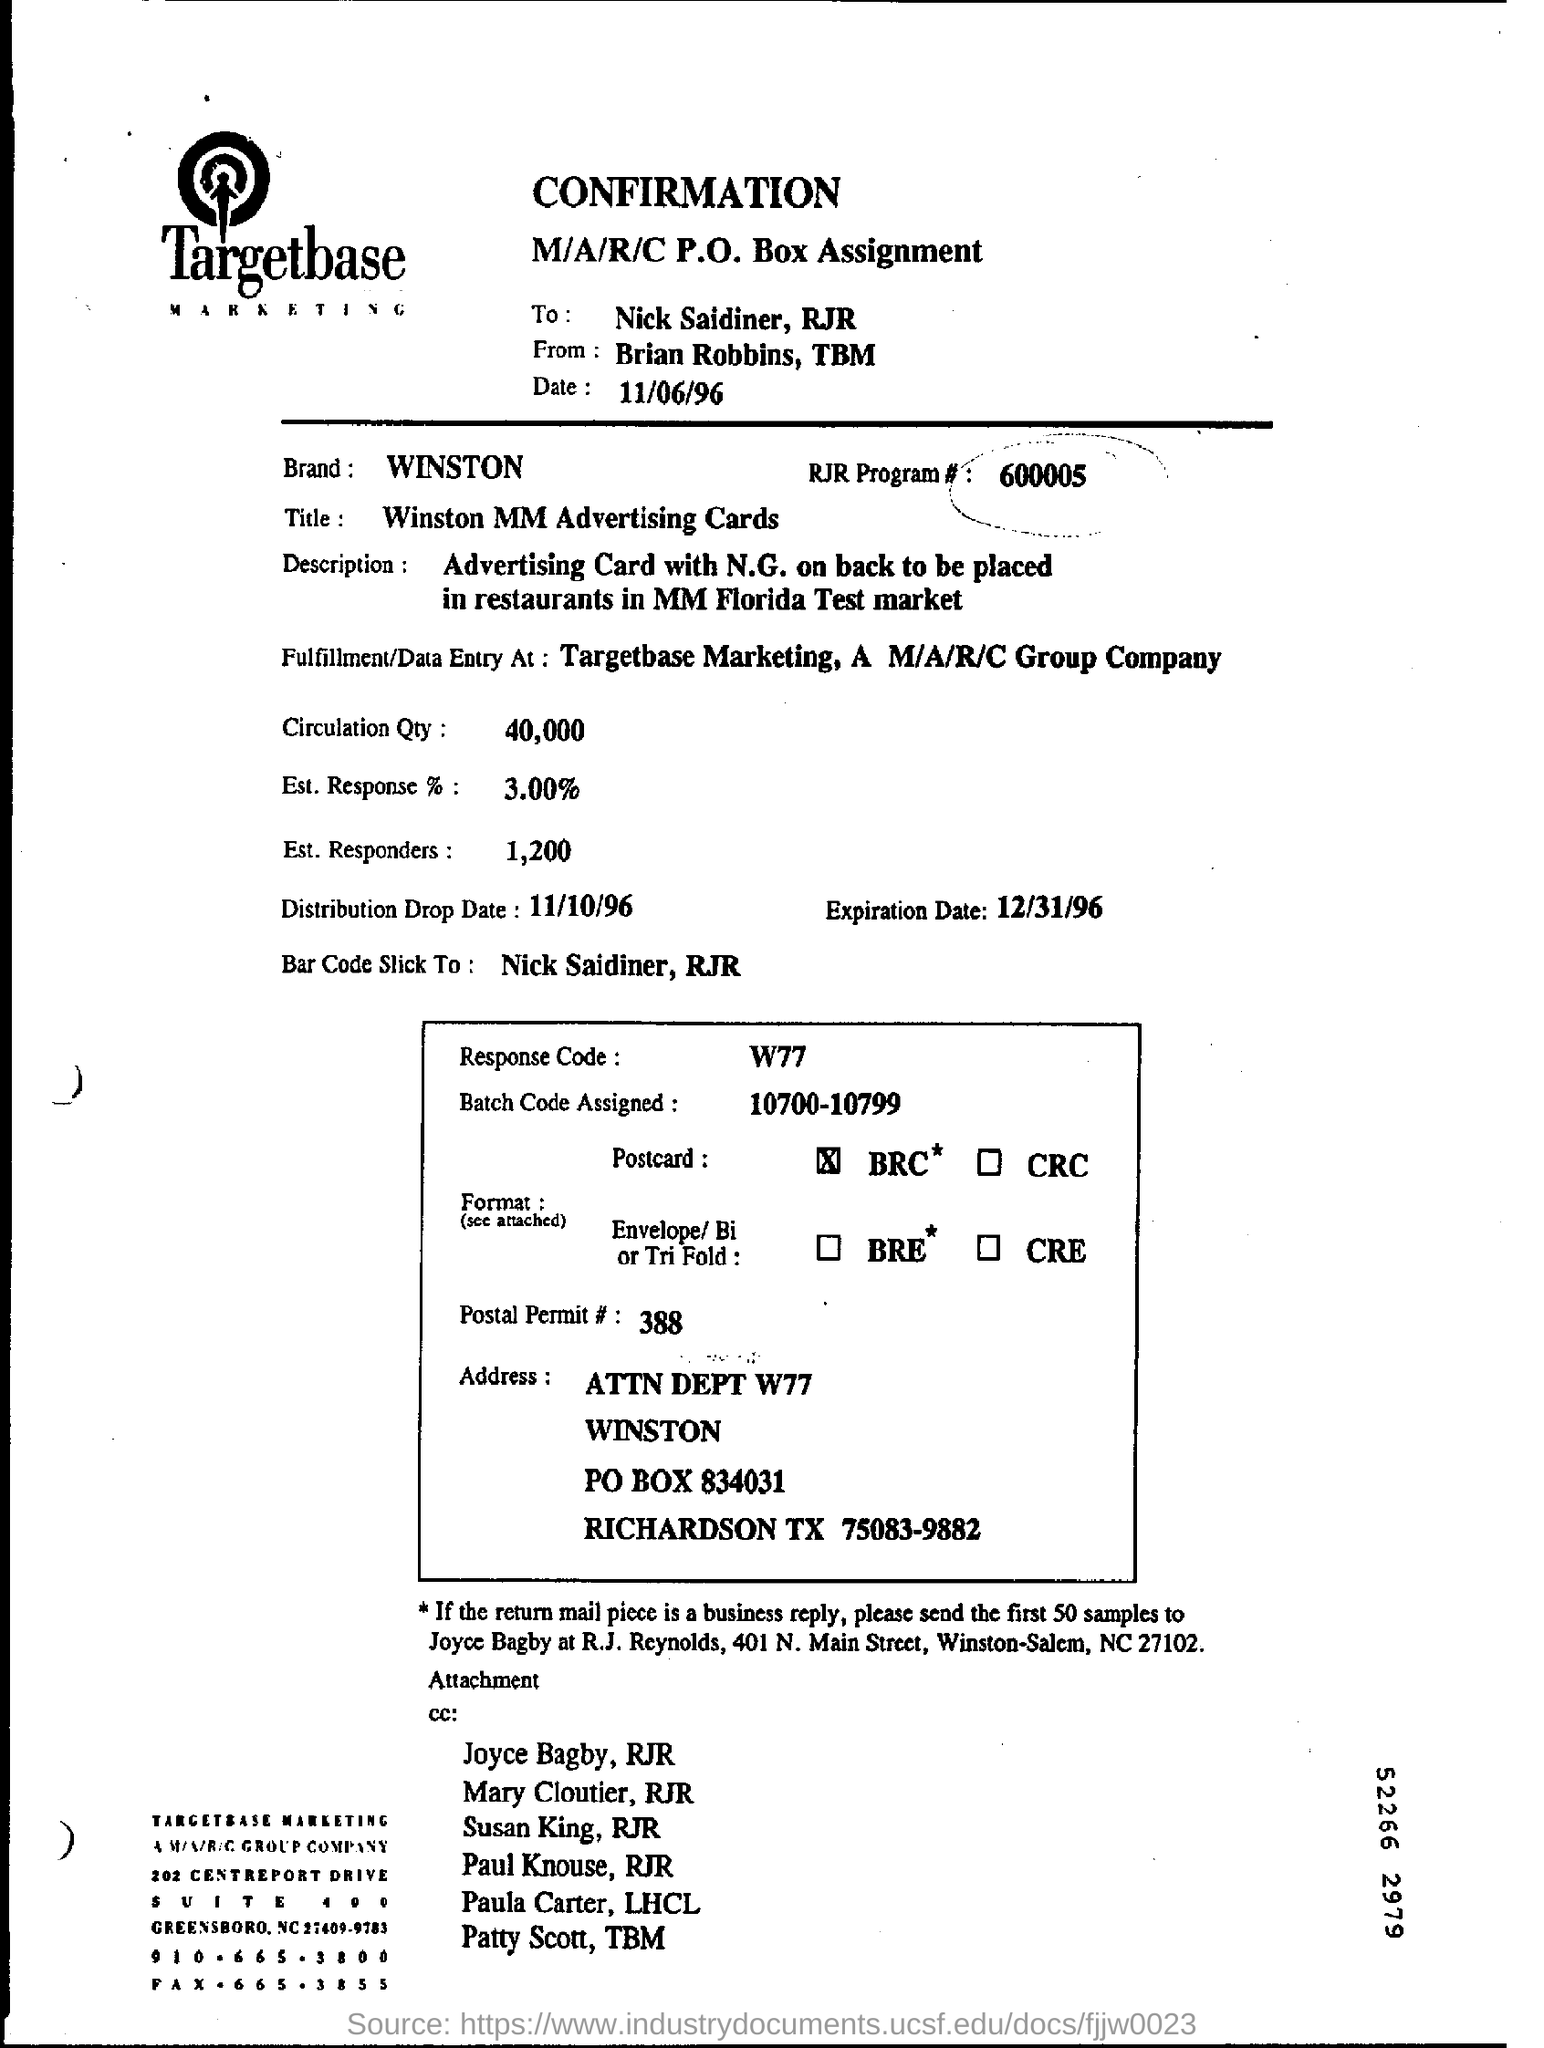What is the Expiration Date mention ?
Offer a very short reply. 12/31/96. Batch Code Assigned is?
Keep it short and to the point. 10700-10799. What is the Response Code Given?
Make the answer very short. W77. 